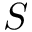Convert formula to latex. <formula><loc_0><loc_0><loc_500><loc_500>S</formula> 